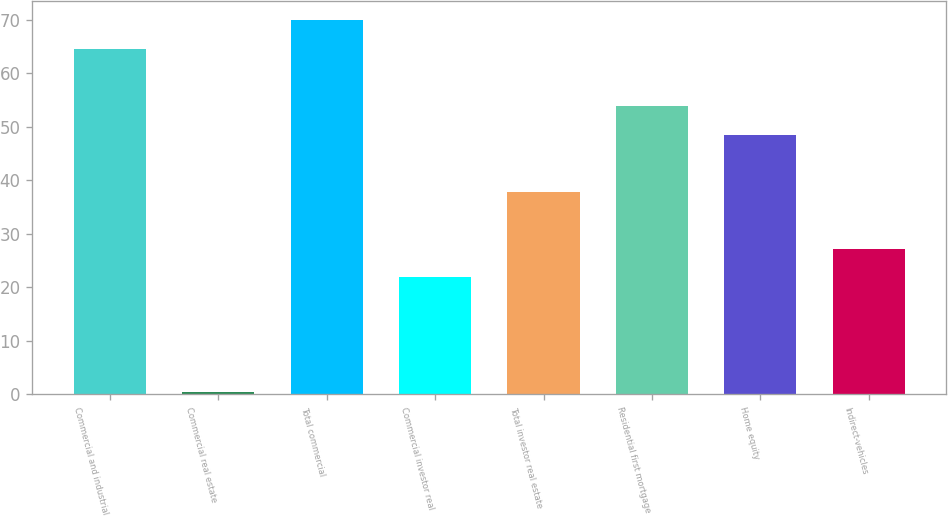<chart> <loc_0><loc_0><loc_500><loc_500><bar_chart><fcel>Commercial and industrial<fcel>Commercial real estate<fcel>Total commercial<fcel>Commercial investor real<fcel>Total investor real estate<fcel>Residential first mortgage<fcel>Home equity<fcel>Indirect-vehicles<nl><fcel>64.58<fcel>0.5<fcel>69.92<fcel>21.86<fcel>37.88<fcel>53.9<fcel>48.56<fcel>27.2<nl></chart> 